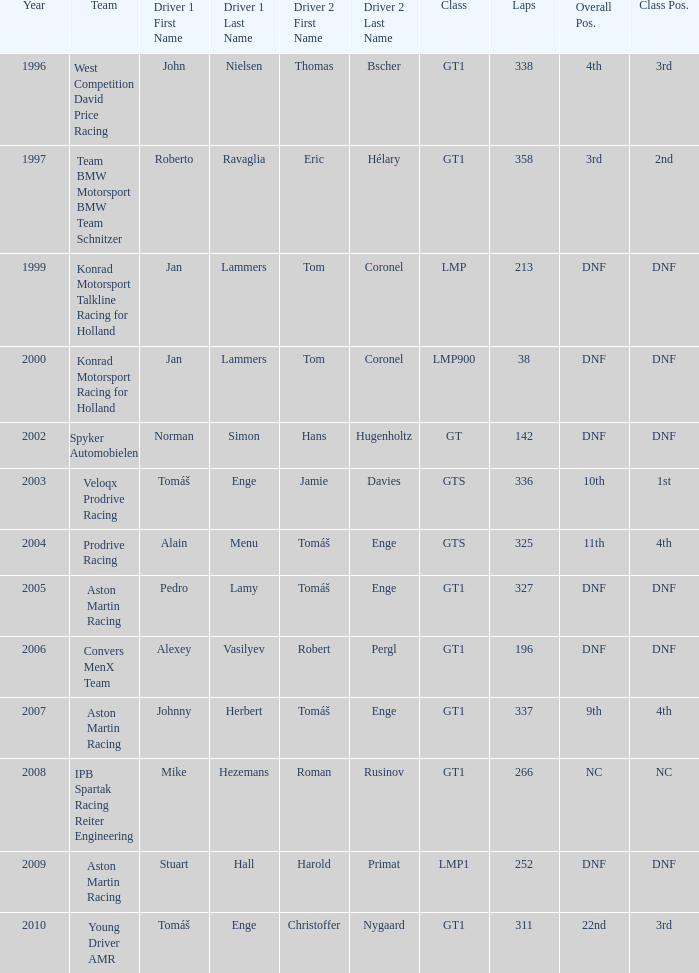In which class had 252 laps and a position of dnf? LMP1. 